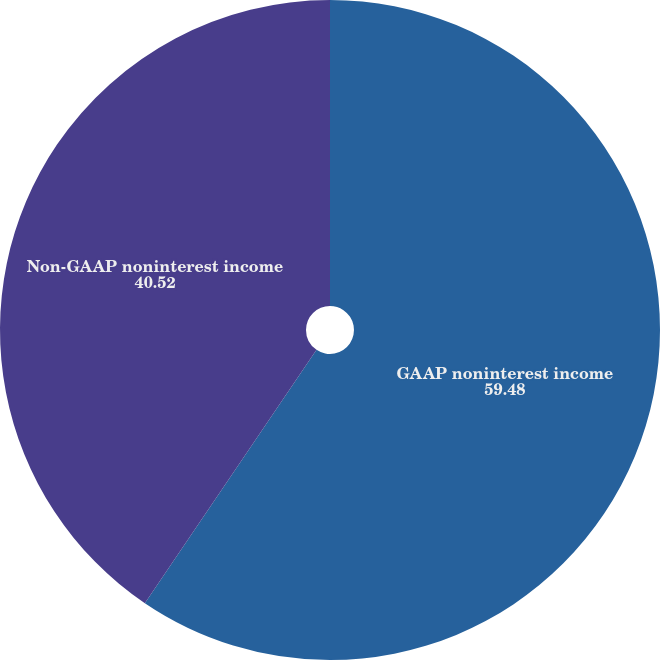Convert chart. <chart><loc_0><loc_0><loc_500><loc_500><pie_chart><fcel>GAAP noninterest income<fcel>Non-GAAP noninterest income<nl><fcel>59.48%<fcel>40.52%<nl></chart> 